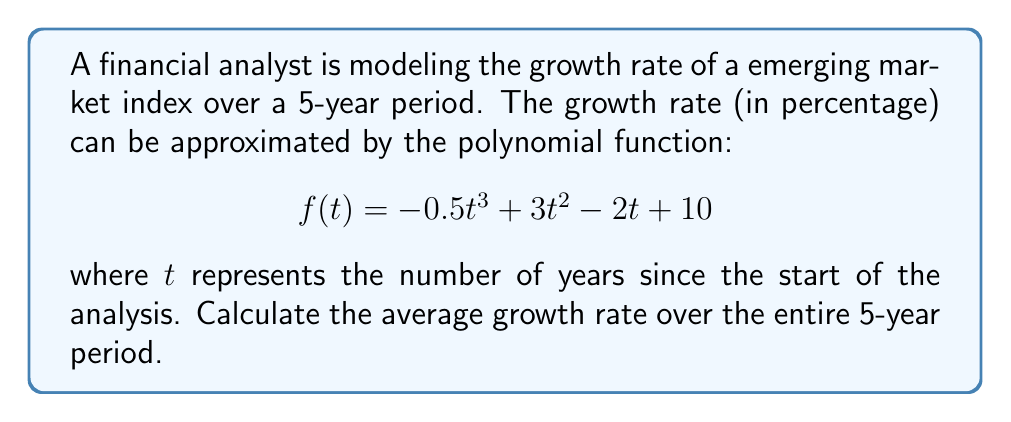Could you help me with this problem? To find the average growth rate over the 5-year period, we need to:

1. Calculate the definite integral of the function from $t=0$ to $t=5$. This gives us the total area under the curve, which represents the cumulative growth over the period.

2. Divide the result by 5 to get the average growth rate per year.

Step 1: Calculate the definite integral

$$ \int_0^5 f(t) dt = \int_0^5 (-0.5t^3 + 3t^2 - 2t + 10) dt $$

Integrating each term:

$$ = \left[ -0.125t^4 + t^3 - t^2 + 10t \right]_0^5 $$

Evaluating at the limits:

$$ = (-0.125(5^4) + 5^3 - 5^2 + 10(5)) - (-0.125(0^4) + 0^3 - 0^2 + 10(0)) $$
$$ = (-78.125 + 125 - 25 + 50) - (0) $$
$$ = 71.875 $$

Step 2: Divide by 5 to get the average

Average growth rate = $\frac{71.875}{5} = 14.375\%$

Therefore, the average growth rate over the 5-year period is 14.375% per year.
Answer: 14.375% 